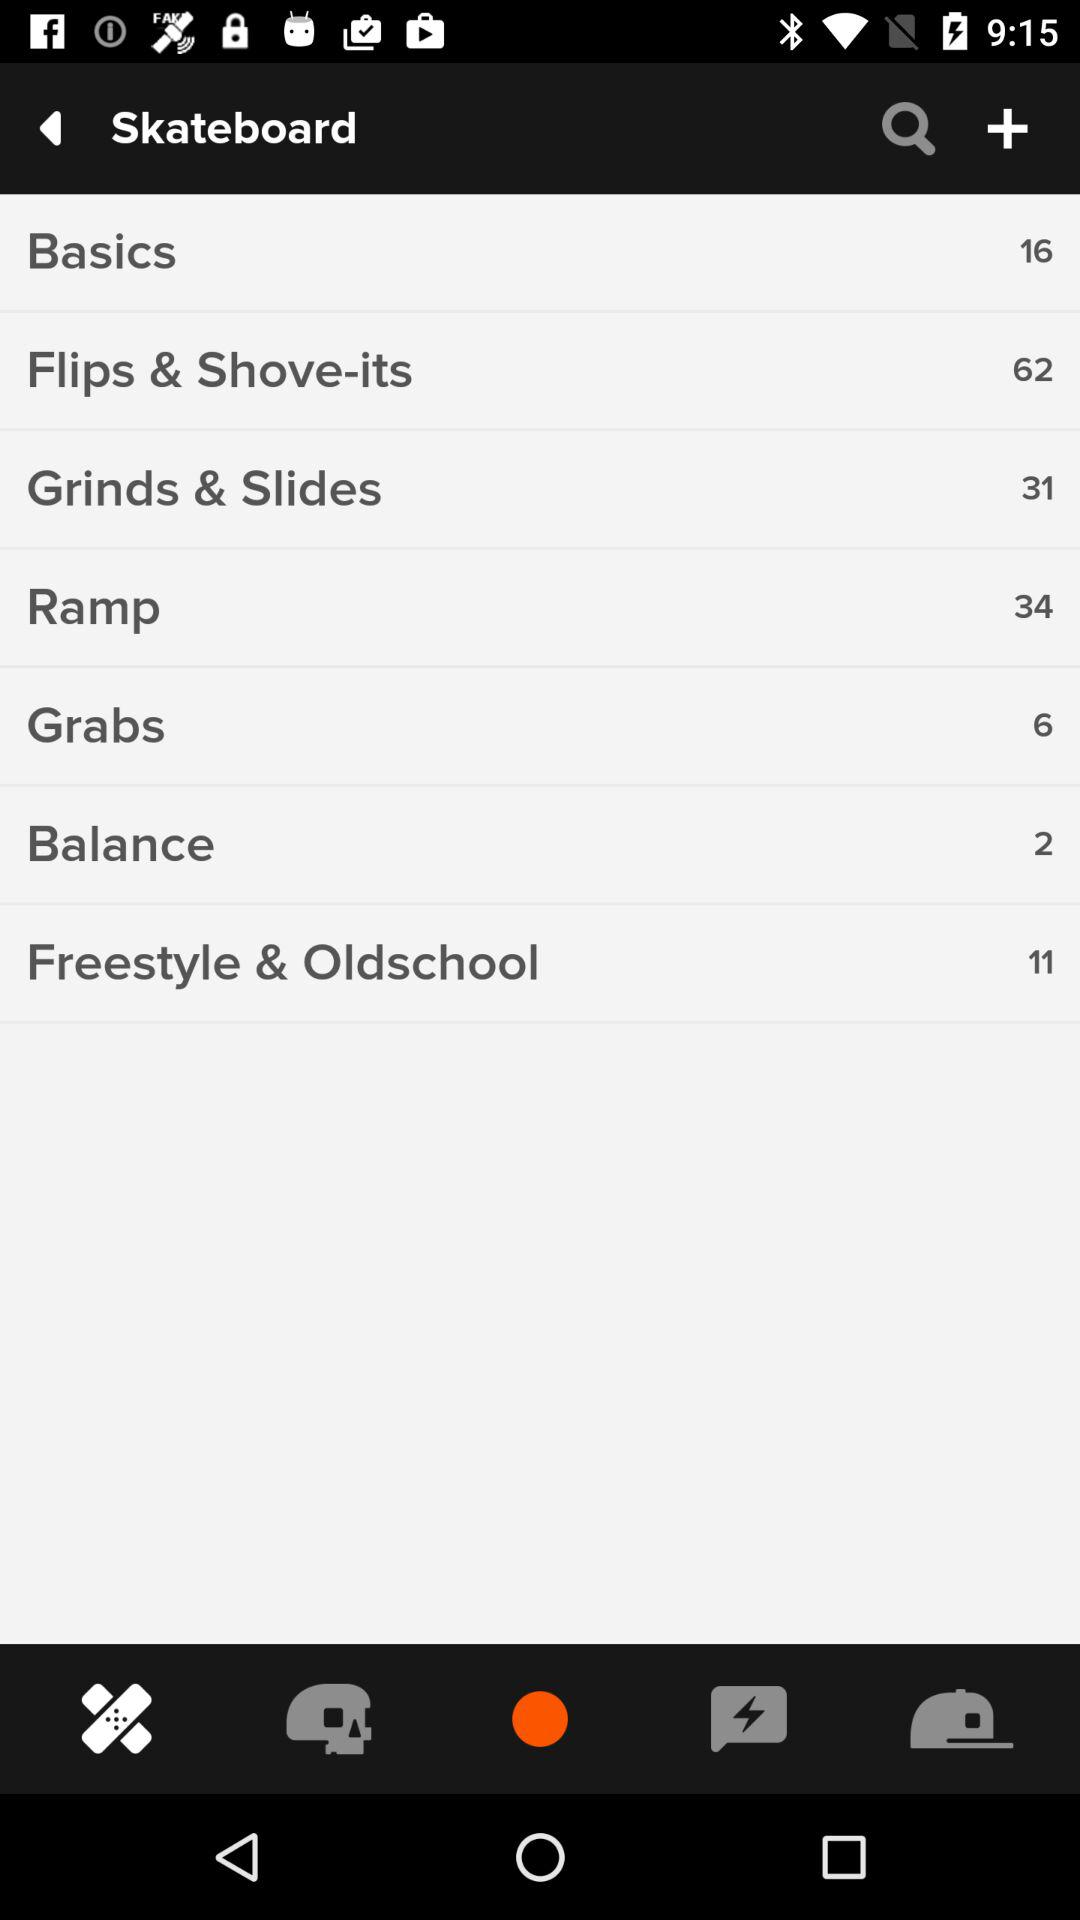How many "Ramp" tricks are there on a skateboard? There are 34 "Ramp" tricks. 